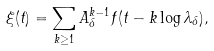Convert formula to latex. <formula><loc_0><loc_0><loc_500><loc_500>\xi ( t ) = \sum _ { k \geq 1 } A _ { \delta } ^ { k - 1 } f ( t - k \log \lambda _ { \delta } ) ,</formula> 